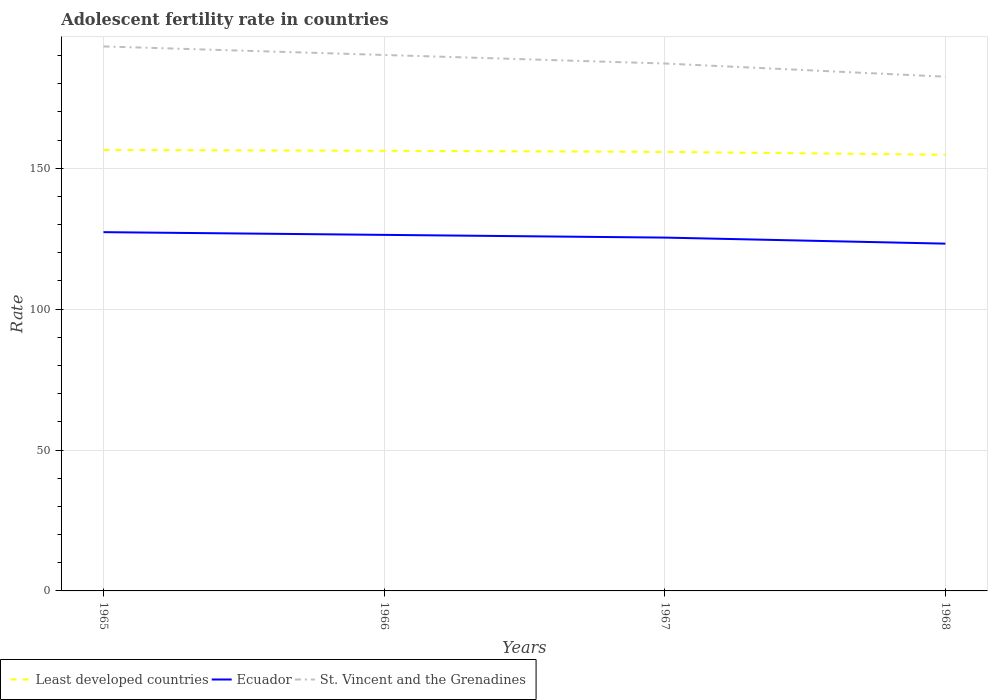How many different coloured lines are there?
Provide a short and direct response. 3. Does the line corresponding to Least developed countries intersect with the line corresponding to Ecuador?
Offer a terse response. No. Is the number of lines equal to the number of legend labels?
Provide a succinct answer. Yes. Across all years, what is the maximum adolescent fertility rate in St. Vincent and the Grenadines?
Your response must be concise. 182.49. In which year was the adolescent fertility rate in Least developed countries maximum?
Give a very brief answer. 1968. What is the total adolescent fertility rate in St. Vincent and the Grenadines in the graph?
Your response must be concise. 10.74. What is the difference between the highest and the second highest adolescent fertility rate in Ecuador?
Offer a terse response. 4.08. What is the difference between the highest and the lowest adolescent fertility rate in Ecuador?
Ensure brevity in your answer.  2. Is the adolescent fertility rate in St. Vincent and the Grenadines strictly greater than the adolescent fertility rate in Ecuador over the years?
Your answer should be compact. No. Are the values on the major ticks of Y-axis written in scientific E-notation?
Provide a succinct answer. No. Does the graph contain any zero values?
Your response must be concise. No. Where does the legend appear in the graph?
Provide a succinct answer. Bottom left. What is the title of the graph?
Offer a terse response. Adolescent fertility rate in countries. Does "Europe(all income levels)" appear as one of the legend labels in the graph?
Give a very brief answer. No. What is the label or title of the X-axis?
Your answer should be very brief. Years. What is the label or title of the Y-axis?
Keep it short and to the point. Rate. What is the Rate of Least developed countries in 1965?
Your response must be concise. 156.49. What is the Rate of Ecuador in 1965?
Offer a terse response. 127.32. What is the Rate in St. Vincent and the Grenadines in 1965?
Your answer should be very brief. 193.23. What is the Rate in Least developed countries in 1966?
Provide a succinct answer. 156.2. What is the Rate in Ecuador in 1966?
Keep it short and to the point. 126.35. What is the Rate in St. Vincent and the Grenadines in 1966?
Your answer should be very brief. 190.2. What is the Rate in Least developed countries in 1967?
Your answer should be compact. 155.8. What is the Rate of Ecuador in 1967?
Your answer should be compact. 125.39. What is the Rate in St. Vincent and the Grenadines in 1967?
Your response must be concise. 187.17. What is the Rate of Least developed countries in 1968?
Give a very brief answer. 154.8. What is the Rate in Ecuador in 1968?
Make the answer very short. 123.24. What is the Rate of St. Vincent and the Grenadines in 1968?
Give a very brief answer. 182.49. Across all years, what is the maximum Rate of Least developed countries?
Your response must be concise. 156.49. Across all years, what is the maximum Rate of Ecuador?
Make the answer very short. 127.32. Across all years, what is the maximum Rate of St. Vincent and the Grenadines?
Give a very brief answer. 193.23. Across all years, what is the minimum Rate of Least developed countries?
Keep it short and to the point. 154.8. Across all years, what is the minimum Rate in Ecuador?
Your response must be concise. 123.24. Across all years, what is the minimum Rate in St. Vincent and the Grenadines?
Give a very brief answer. 182.49. What is the total Rate of Least developed countries in the graph?
Keep it short and to the point. 623.29. What is the total Rate of Ecuador in the graph?
Offer a very short reply. 502.31. What is the total Rate in St. Vincent and the Grenadines in the graph?
Your response must be concise. 753.09. What is the difference between the Rate in Least developed countries in 1965 and that in 1966?
Offer a terse response. 0.29. What is the difference between the Rate in Ecuador in 1965 and that in 1966?
Make the answer very short. 0.97. What is the difference between the Rate in St. Vincent and the Grenadines in 1965 and that in 1966?
Give a very brief answer. 3.03. What is the difference between the Rate in Least developed countries in 1965 and that in 1967?
Give a very brief answer. 0.68. What is the difference between the Rate of Ecuador in 1965 and that in 1967?
Offer a terse response. 1.93. What is the difference between the Rate of St. Vincent and the Grenadines in 1965 and that in 1967?
Give a very brief answer. 6.06. What is the difference between the Rate in Least developed countries in 1965 and that in 1968?
Your answer should be very brief. 1.69. What is the difference between the Rate in Ecuador in 1965 and that in 1968?
Your answer should be compact. 4.08. What is the difference between the Rate in St. Vincent and the Grenadines in 1965 and that in 1968?
Ensure brevity in your answer.  10.74. What is the difference between the Rate in Least developed countries in 1966 and that in 1967?
Your response must be concise. 0.4. What is the difference between the Rate of Ecuador in 1966 and that in 1967?
Keep it short and to the point. 0.97. What is the difference between the Rate of St. Vincent and the Grenadines in 1966 and that in 1967?
Offer a terse response. 3.03. What is the difference between the Rate in Least developed countries in 1966 and that in 1968?
Offer a very short reply. 1.4. What is the difference between the Rate in Ecuador in 1966 and that in 1968?
Offer a terse response. 3.11. What is the difference between the Rate in St. Vincent and the Grenadines in 1966 and that in 1968?
Your answer should be compact. 7.71. What is the difference between the Rate in Ecuador in 1967 and that in 1968?
Your answer should be compact. 2.15. What is the difference between the Rate in St. Vincent and the Grenadines in 1967 and that in 1968?
Give a very brief answer. 4.68. What is the difference between the Rate of Least developed countries in 1965 and the Rate of Ecuador in 1966?
Provide a succinct answer. 30.13. What is the difference between the Rate of Least developed countries in 1965 and the Rate of St. Vincent and the Grenadines in 1966?
Provide a short and direct response. -33.71. What is the difference between the Rate of Ecuador in 1965 and the Rate of St. Vincent and the Grenadines in 1966?
Provide a succinct answer. -62.88. What is the difference between the Rate of Least developed countries in 1965 and the Rate of Ecuador in 1967?
Your answer should be compact. 31.1. What is the difference between the Rate of Least developed countries in 1965 and the Rate of St. Vincent and the Grenadines in 1967?
Your answer should be very brief. -30.69. What is the difference between the Rate in Ecuador in 1965 and the Rate in St. Vincent and the Grenadines in 1967?
Your response must be concise. -59.85. What is the difference between the Rate in Least developed countries in 1965 and the Rate in Ecuador in 1968?
Offer a very short reply. 33.24. What is the difference between the Rate in Least developed countries in 1965 and the Rate in St. Vincent and the Grenadines in 1968?
Keep it short and to the point. -26. What is the difference between the Rate in Ecuador in 1965 and the Rate in St. Vincent and the Grenadines in 1968?
Your answer should be very brief. -55.17. What is the difference between the Rate of Least developed countries in 1966 and the Rate of Ecuador in 1967?
Provide a short and direct response. 30.81. What is the difference between the Rate of Least developed countries in 1966 and the Rate of St. Vincent and the Grenadines in 1967?
Provide a short and direct response. -30.98. What is the difference between the Rate in Ecuador in 1966 and the Rate in St. Vincent and the Grenadines in 1967?
Your response must be concise. -60.82. What is the difference between the Rate of Least developed countries in 1966 and the Rate of Ecuador in 1968?
Your response must be concise. 32.95. What is the difference between the Rate in Least developed countries in 1966 and the Rate in St. Vincent and the Grenadines in 1968?
Offer a terse response. -26.29. What is the difference between the Rate in Ecuador in 1966 and the Rate in St. Vincent and the Grenadines in 1968?
Make the answer very short. -56.14. What is the difference between the Rate of Least developed countries in 1967 and the Rate of Ecuador in 1968?
Make the answer very short. 32.56. What is the difference between the Rate in Least developed countries in 1967 and the Rate in St. Vincent and the Grenadines in 1968?
Provide a short and direct response. -26.69. What is the difference between the Rate in Ecuador in 1967 and the Rate in St. Vincent and the Grenadines in 1968?
Offer a very short reply. -57.1. What is the average Rate of Least developed countries per year?
Give a very brief answer. 155.82. What is the average Rate of Ecuador per year?
Give a very brief answer. 125.58. What is the average Rate of St. Vincent and the Grenadines per year?
Give a very brief answer. 188.27. In the year 1965, what is the difference between the Rate in Least developed countries and Rate in Ecuador?
Ensure brevity in your answer.  29.17. In the year 1965, what is the difference between the Rate in Least developed countries and Rate in St. Vincent and the Grenadines?
Offer a very short reply. -36.74. In the year 1965, what is the difference between the Rate in Ecuador and Rate in St. Vincent and the Grenadines?
Offer a terse response. -65.91. In the year 1966, what is the difference between the Rate in Least developed countries and Rate in Ecuador?
Your response must be concise. 29.84. In the year 1966, what is the difference between the Rate in Least developed countries and Rate in St. Vincent and the Grenadines?
Ensure brevity in your answer.  -34. In the year 1966, what is the difference between the Rate in Ecuador and Rate in St. Vincent and the Grenadines?
Keep it short and to the point. -63.85. In the year 1967, what is the difference between the Rate of Least developed countries and Rate of Ecuador?
Offer a very short reply. 30.41. In the year 1967, what is the difference between the Rate in Least developed countries and Rate in St. Vincent and the Grenadines?
Provide a succinct answer. -31.37. In the year 1967, what is the difference between the Rate of Ecuador and Rate of St. Vincent and the Grenadines?
Offer a terse response. -61.78. In the year 1968, what is the difference between the Rate of Least developed countries and Rate of Ecuador?
Offer a terse response. 31.56. In the year 1968, what is the difference between the Rate in Least developed countries and Rate in St. Vincent and the Grenadines?
Offer a terse response. -27.69. In the year 1968, what is the difference between the Rate of Ecuador and Rate of St. Vincent and the Grenadines?
Offer a very short reply. -59.25. What is the ratio of the Rate of Ecuador in 1965 to that in 1966?
Ensure brevity in your answer.  1.01. What is the ratio of the Rate in St. Vincent and the Grenadines in 1965 to that in 1966?
Ensure brevity in your answer.  1.02. What is the ratio of the Rate in Least developed countries in 1965 to that in 1967?
Offer a very short reply. 1. What is the ratio of the Rate of Ecuador in 1965 to that in 1967?
Ensure brevity in your answer.  1.02. What is the ratio of the Rate in St. Vincent and the Grenadines in 1965 to that in 1967?
Offer a very short reply. 1.03. What is the ratio of the Rate of Least developed countries in 1965 to that in 1968?
Your answer should be very brief. 1.01. What is the ratio of the Rate in Ecuador in 1965 to that in 1968?
Your answer should be very brief. 1.03. What is the ratio of the Rate in St. Vincent and the Grenadines in 1965 to that in 1968?
Offer a terse response. 1.06. What is the ratio of the Rate in Ecuador in 1966 to that in 1967?
Give a very brief answer. 1.01. What is the ratio of the Rate in St. Vincent and the Grenadines in 1966 to that in 1967?
Make the answer very short. 1.02. What is the ratio of the Rate in Ecuador in 1966 to that in 1968?
Your answer should be very brief. 1.03. What is the ratio of the Rate of St. Vincent and the Grenadines in 1966 to that in 1968?
Provide a short and direct response. 1.04. What is the ratio of the Rate in Ecuador in 1967 to that in 1968?
Provide a short and direct response. 1.02. What is the ratio of the Rate of St. Vincent and the Grenadines in 1967 to that in 1968?
Give a very brief answer. 1.03. What is the difference between the highest and the second highest Rate in Least developed countries?
Keep it short and to the point. 0.29. What is the difference between the highest and the second highest Rate of Ecuador?
Your response must be concise. 0.97. What is the difference between the highest and the second highest Rate of St. Vincent and the Grenadines?
Provide a short and direct response. 3.03. What is the difference between the highest and the lowest Rate of Least developed countries?
Make the answer very short. 1.69. What is the difference between the highest and the lowest Rate of Ecuador?
Keep it short and to the point. 4.08. What is the difference between the highest and the lowest Rate of St. Vincent and the Grenadines?
Give a very brief answer. 10.74. 